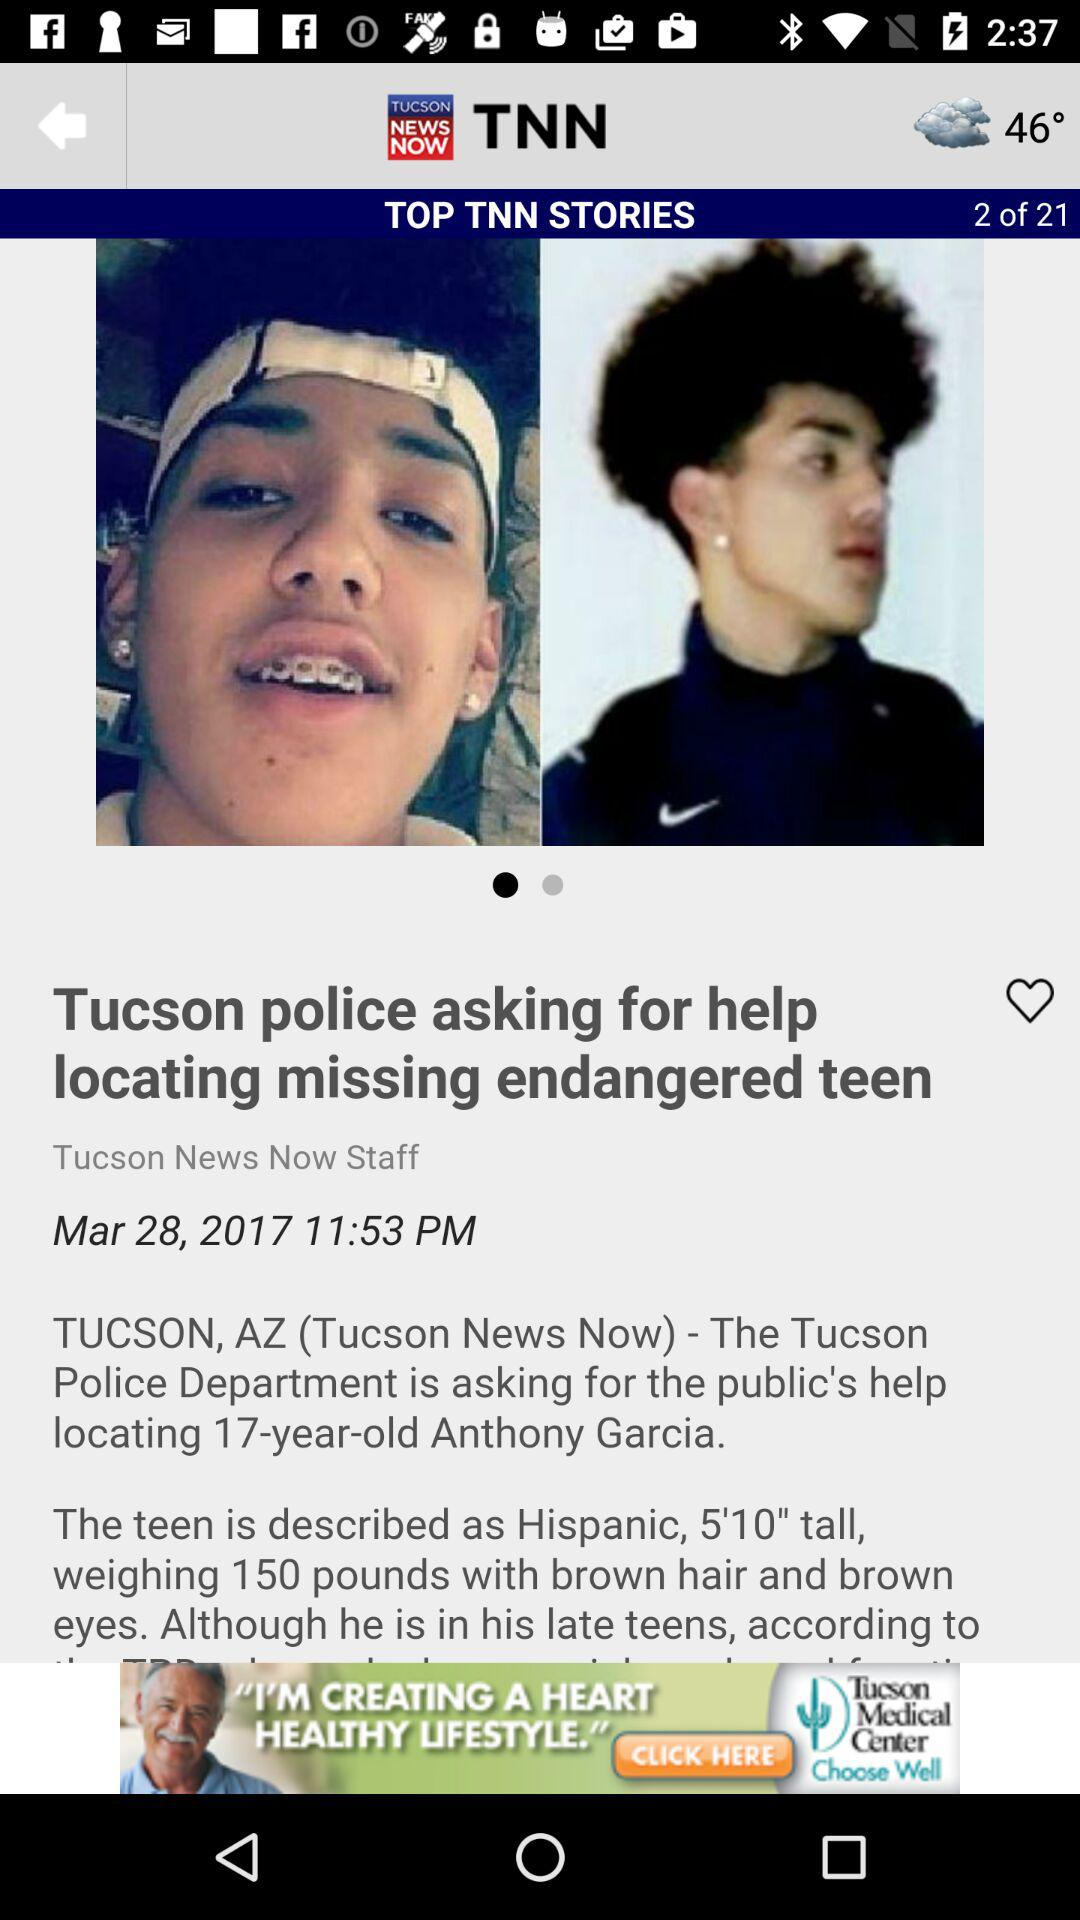When was the article published? The article was published on March 28, 2017 at 11:53 pm. 